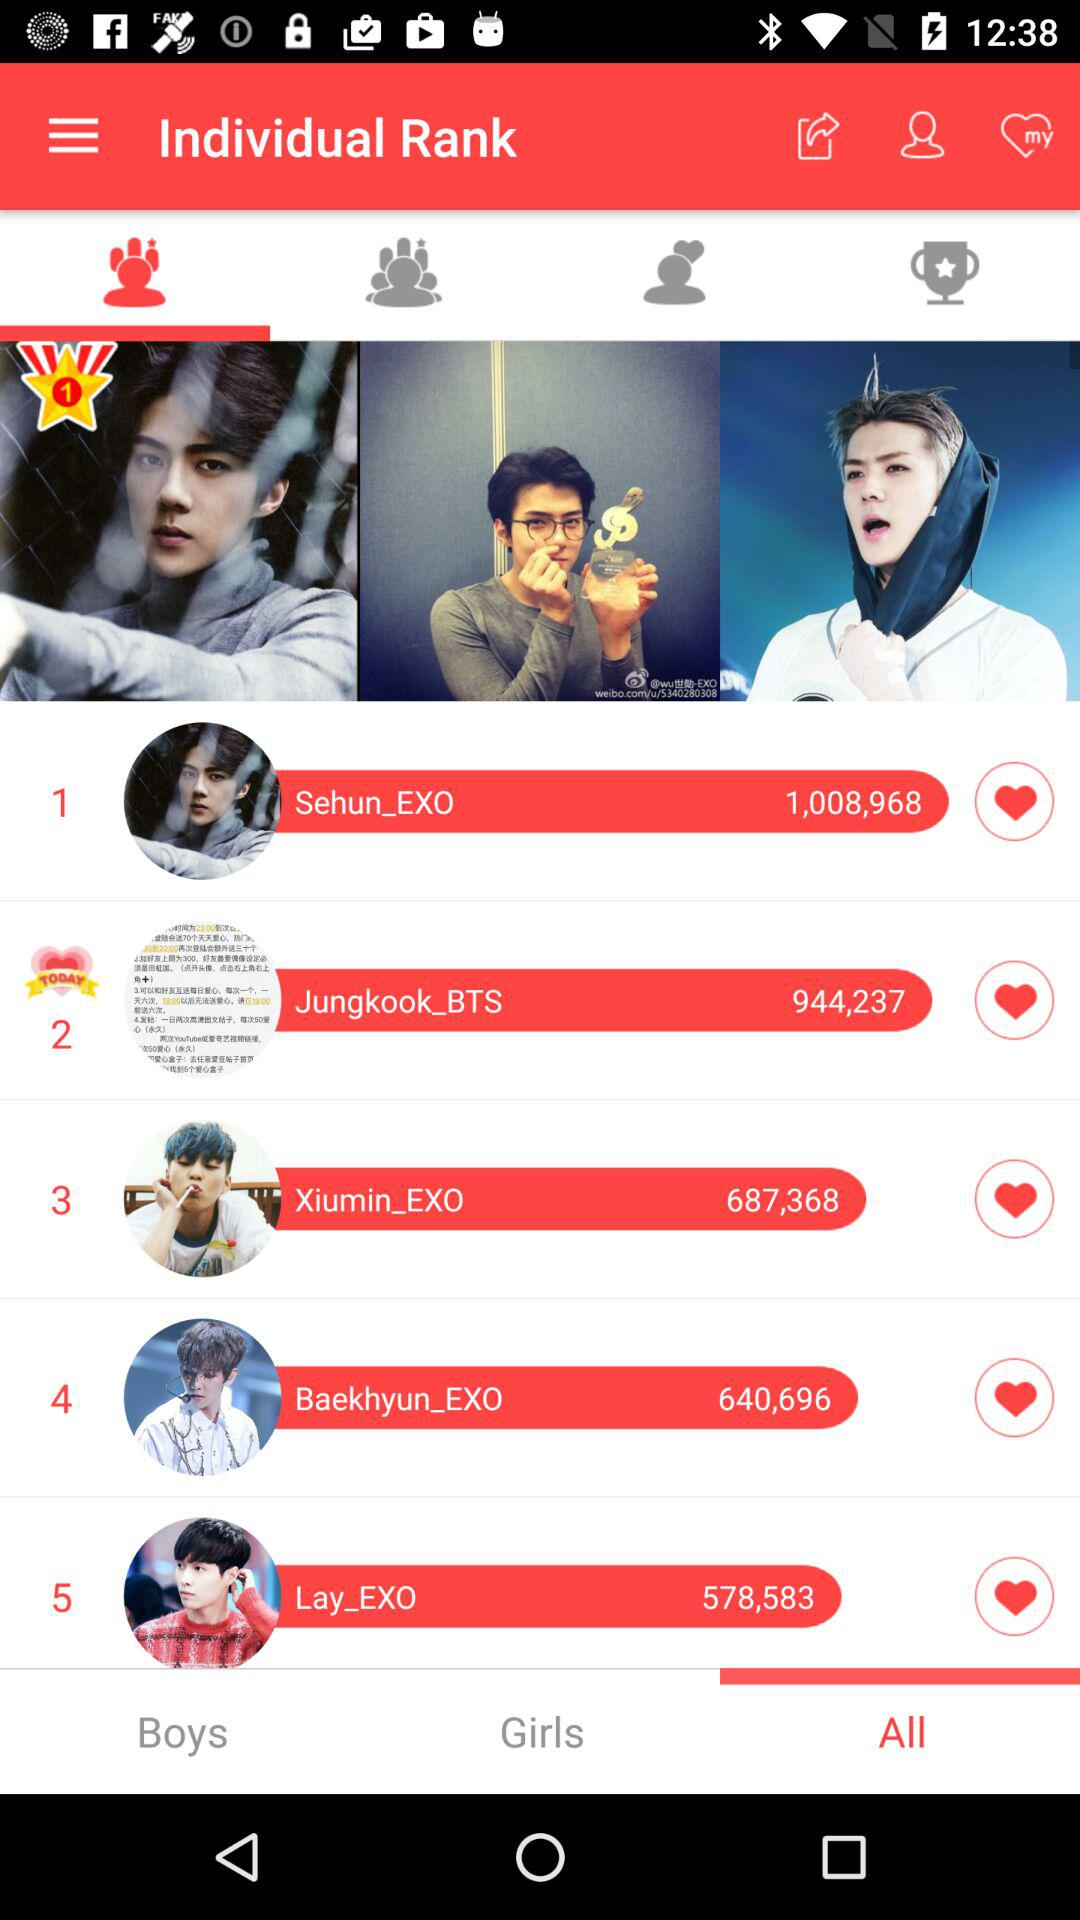Which tab is selected?
When the provided information is insufficient, respond with <no answer>. <no answer> 